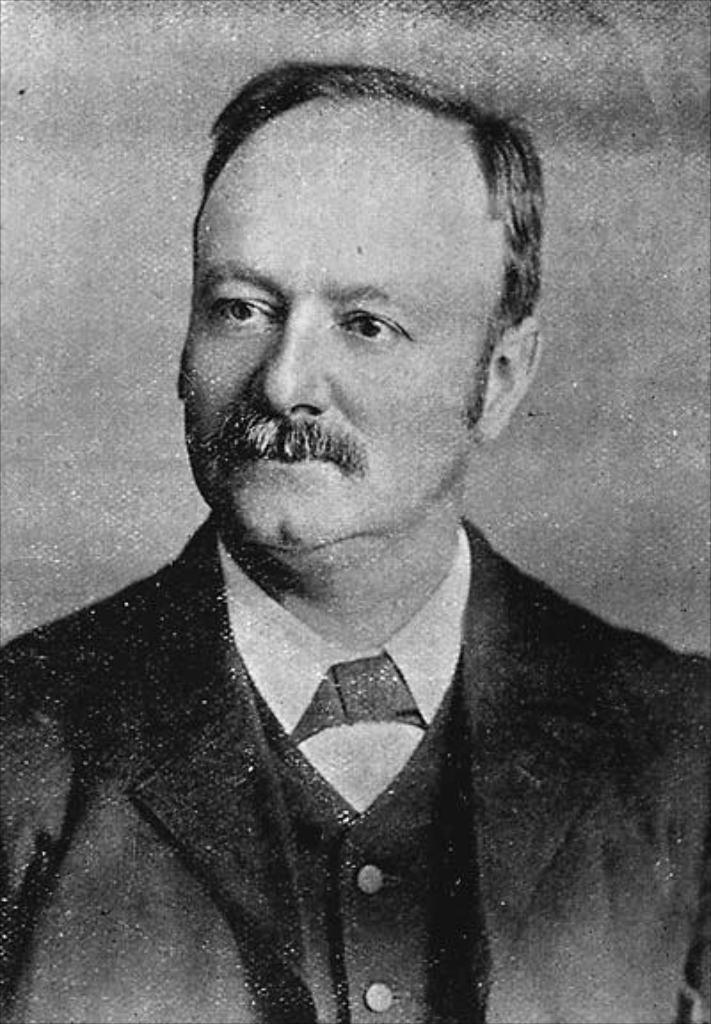What is the main subject of the image? There is a picture of a man in the image. What can be said about the color scheme of the image? The image is black and white in color. How many lizards can be seen crawling on the car in the image? There is no car or lizards present in the image; it features a picture of a man in black and white. 